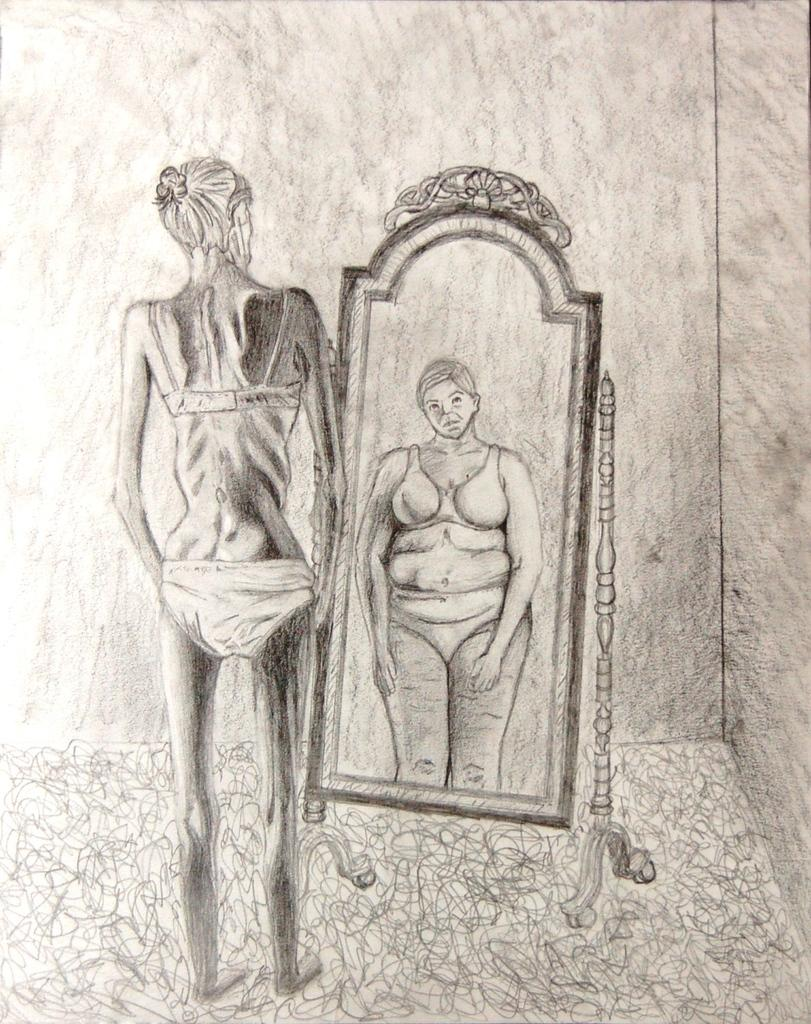What type of drawing is shown in the image? The image is a sketch. Who is the main subject of the sketch? There is a lady depicted in the sketch. What object is present on the right side of the sketch? There is visible through the mirror in the sketch. How many ladies are depicted in the sketch? There are two ladies depicted in the sketch, one directly and another through the mirror. What company does the boy in the sketch work for? There is no boy present in the sketch; it only depicts two ladies. 